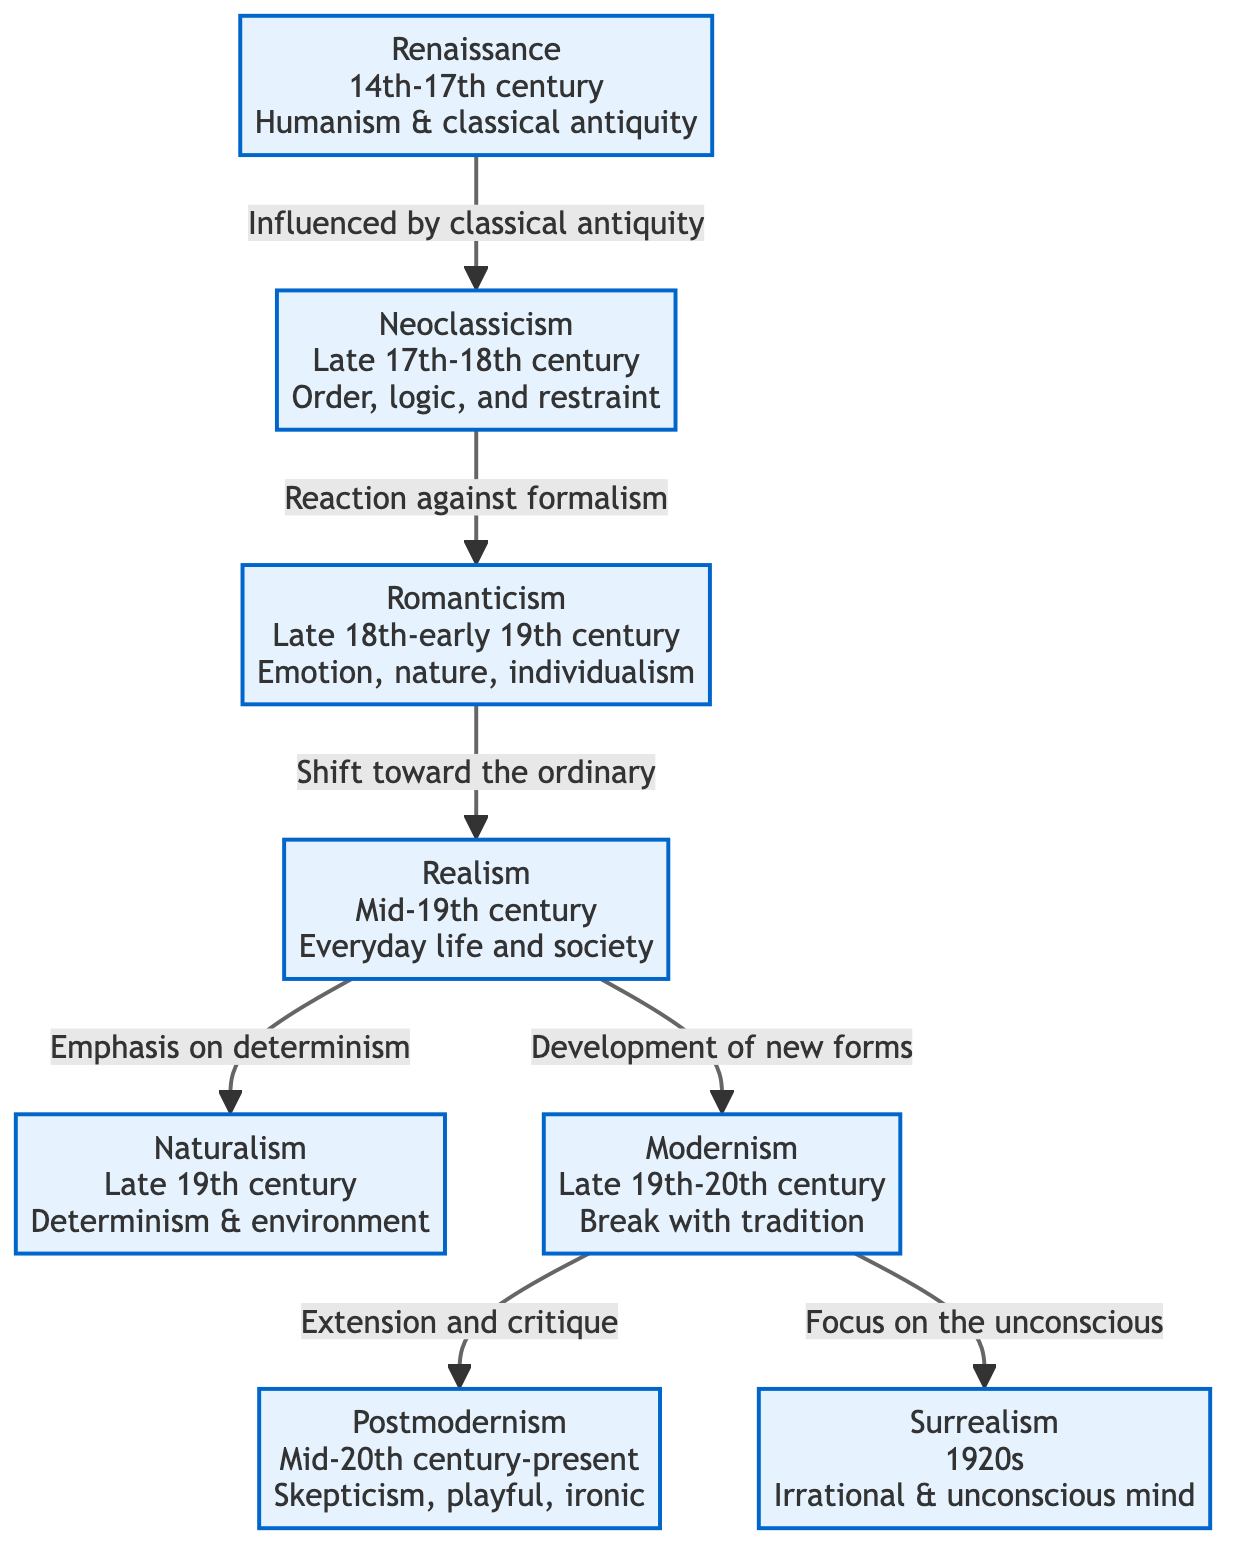What are the time periods for Romanticism? According to the diagram, Romanticism spans from the late 18th century to the early 19th century.
Answer: Late 18th-early 19th century How many literary movements are depicted in the diagram? By counting all the distinct movements listed in the diagram, there are a total of eight movements shown.
Answer: 8 What movement comes after Realism? The arrows in the diagram show that both Naturalism and Modernism follow Realism, but since only the first one in order is usually considered, the answer is Naturalism.
Answer: Naturalism Which movement is characterized by 'Skepticism, playful, ironic'? The diagram indicates that Postmodernism is defined by these characteristics.
Answer: Postmodernism What characterizes Neoclassicism? The diagram states that Neoclassicism is characterized by order, logic, and restraint.
Answer: Order, logic, and restraint Which literary movement reacts against formalism? The diagram specifies that Romanticism is a reaction against Neoclassicism, which is associated with formalism.
Answer: Romanticism What is the relationship between Modernism and Surrealism? The diagram indicates that Modernism leads to Surrealism, highlighting a focus on the unconscious.
Answer: Modernism leads to Surrealism What is the earliest movement mentioned in the diagram? The flowchart presents Renaissance as the first movement chronologically.
Answer: Renaissance 